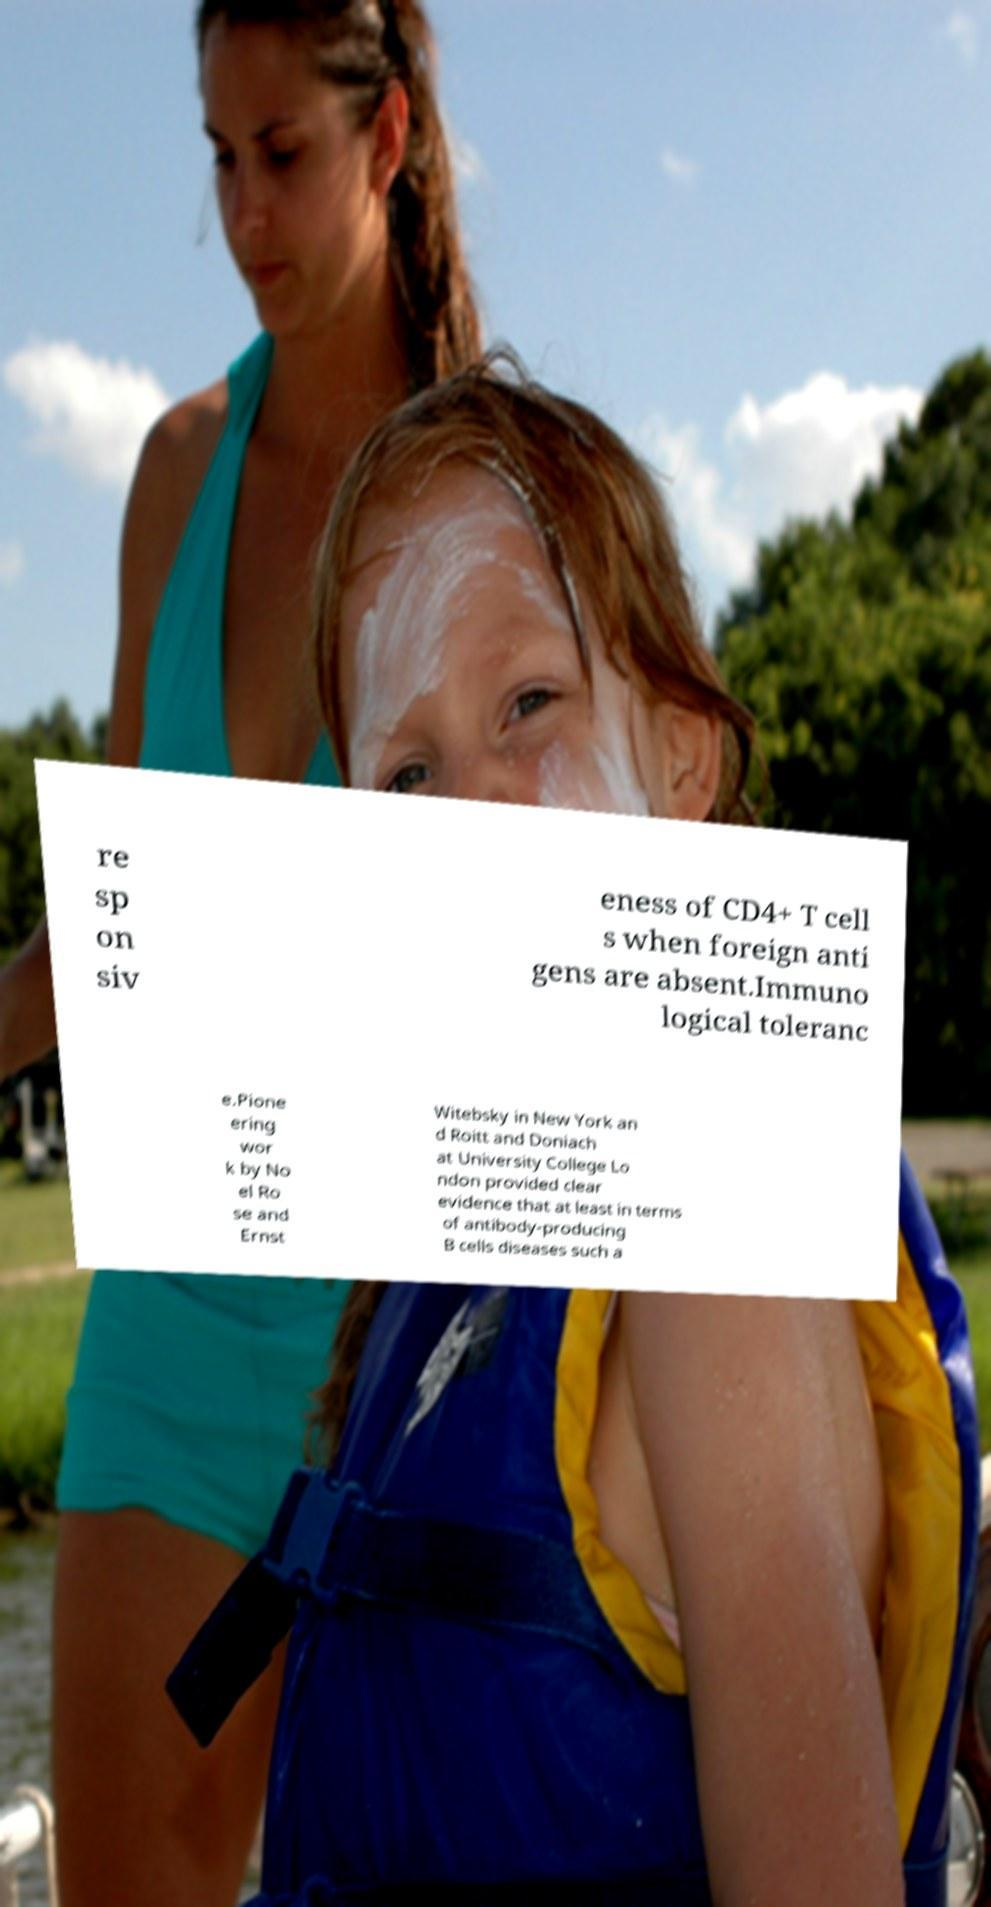Please read and relay the text visible in this image. What does it say? re sp on siv eness of CD4+ T cell s when foreign anti gens are absent.Immuno logical toleranc e.Pione ering wor k by No el Ro se and Ernst Witebsky in New York an d Roitt and Doniach at University College Lo ndon provided clear evidence that at least in terms of antibody-producing B cells diseases such a 